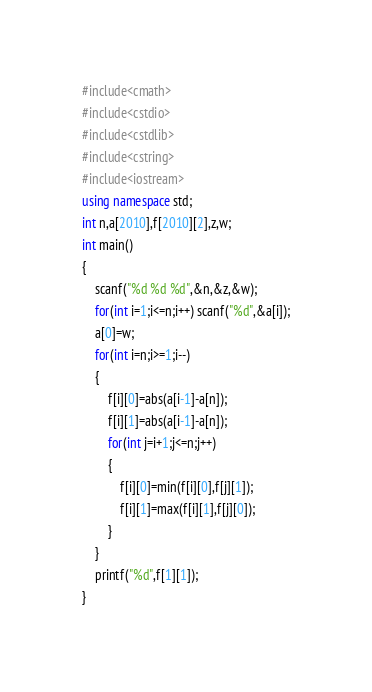<code> <loc_0><loc_0><loc_500><loc_500><_C++_>#include<cmath>
#include<cstdio>
#include<cstdlib>
#include<cstring>
#include<iostream>
using namespace std;
int n,a[2010],f[2010][2],z,w;
int main()
{
	scanf("%d %d %d",&n,&z,&w);
	for(int i=1;i<=n;i++) scanf("%d",&a[i]);
	a[0]=w;
	for(int i=n;i>=1;i--)
	{
		f[i][0]=abs(a[i-1]-a[n]);
		f[i][1]=abs(a[i-1]-a[n]);
		for(int j=i+1;j<=n;j++)
		{
			f[i][0]=min(f[i][0],f[j][1]);
			f[i][1]=max(f[i][1],f[j][0]);
		}
	}
	printf("%d",f[1][1]);
}</code> 